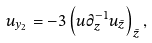Convert formula to latex. <formula><loc_0><loc_0><loc_500><loc_500>u _ { y _ { 2 } } = - 3 \left ( u \partial _ { z } ^ { - 1 } u _ { \bar { z } } \right ) _ { \bar { z } } ,</formula> 